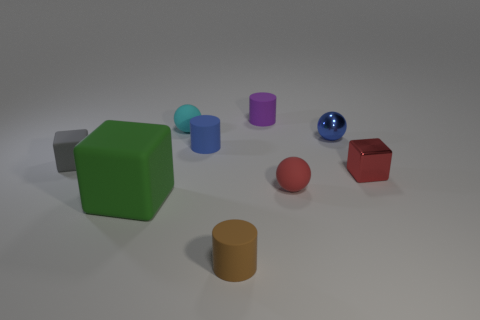Subtract all cylinders. How many objects are left? 6 Add 9 large objects. How many large objects exist? 10 Subtract 0 cyan cubes. How many objects are left? 9 Subtract all green rubber things. Subtract all rubber balls. How many objects are left? 6 Add 6 blue things. How many blue things are left? 8 